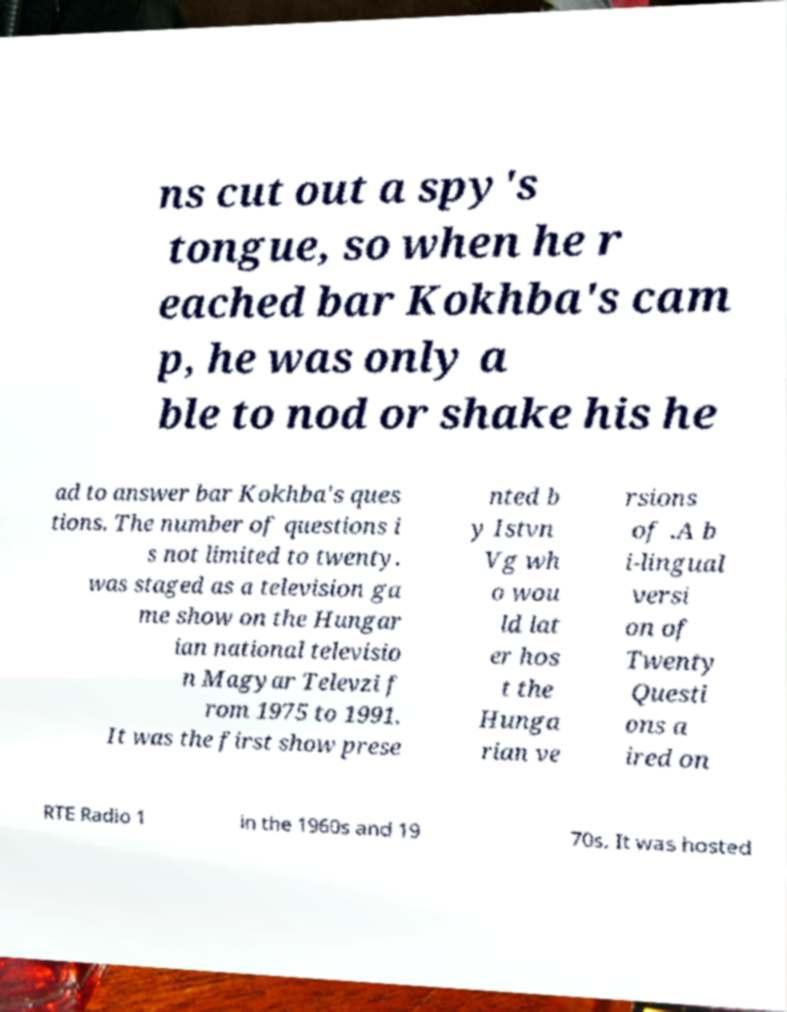For documentation purposes, I need the text within this image transcribed. Could you provide that? ns cut out a spy's tongue, so when he r eached bar Kokhba's cam p, he was only a ble to nod or shake his he ad to answer bar Kokhba's ques tions. The number of questions i s not limited to twenty. was staged as a television ga me show on the Hungar ian national televisio n Magyar Televzi f rom 1975 to 1991. It was the first show prese nted b y Istvn Vg wh o wou ld lat er hos t the Hunga rian ve rsions of .A b i-lingual versi on of Twenty Questi ons a ired on RTE Radio 1 in the 1960s and 19 70s. It was hosted 